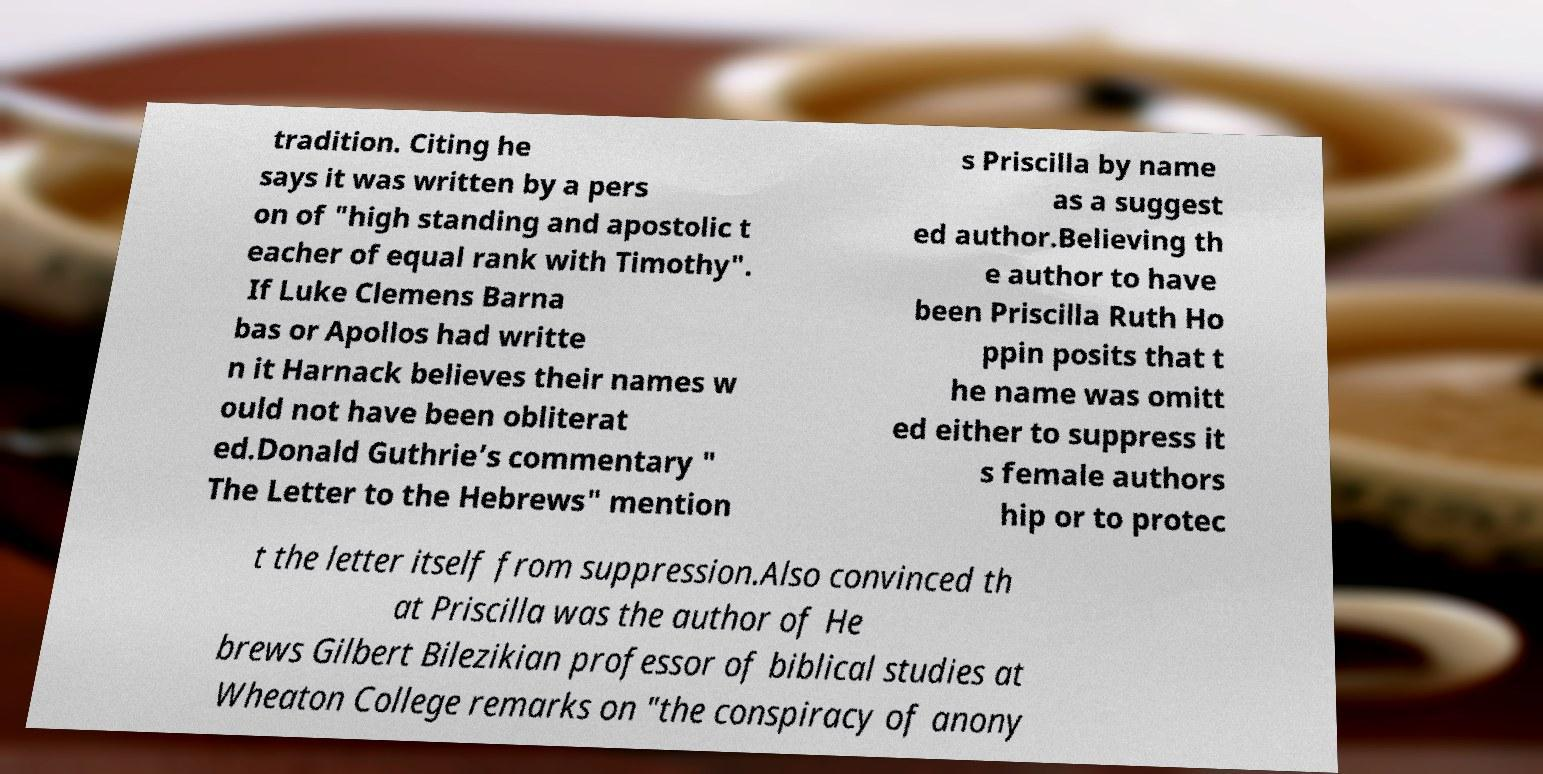Please read and relay the text visible in this image. What does it say? tradition. Citing he says it was written by a pers on of "high standing and apostolic t eacher of equal rank with Timothy". If Luke Clemens Barna bas or Apollos had writte n it Harnack believes their names w ould not have been obliterat ed.Donald Guthrie’s commentary " The Letter to the Hebrews" mention s Priscilla by name as a suggest ed author.Believing th e author to have been Priscilla Ruth Ho ppin posits that t he name was omitt ed either to suppress it s female authors hip or to protec t the letter itself from suppression.Also convinced th at Priscilla was the author of He brews Gilbert Bilezikian professor of biblical studies at Wheaton College remarks on "the conspiracy of anony 